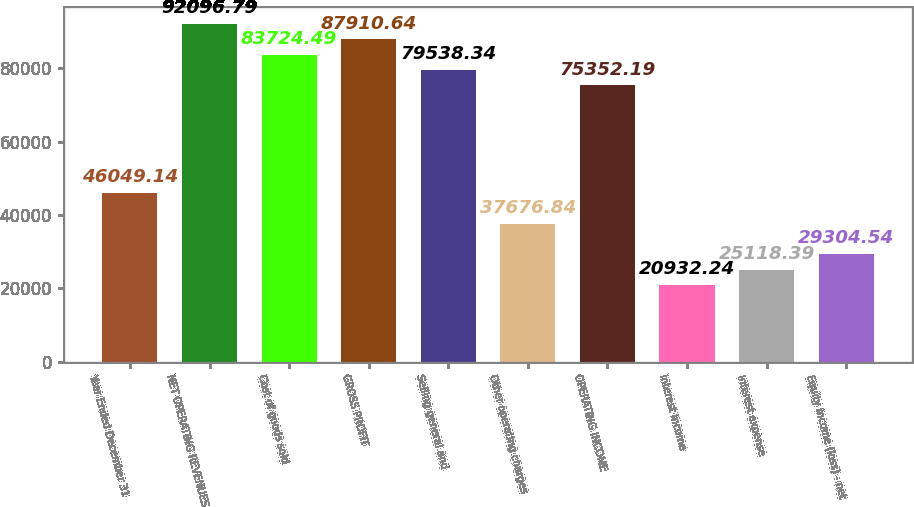<chart> <loc_0><loc_0><loc_500><loc_500><bar_chart><fcel>Year Ended December 31<fcel>NET OPERATING REVENUES<fcel>Cost of goods sold<fcel>GROSS PROFIT<fcel>Selling general and<fcel>Other operating charges<fcel>OPERATING INCOME<fcel>Interest income<fcel>Interest expense<fcel>Equity income (loss) - net<nl><fcel>46049.1<fcel>92096.8<fcel>83724.5<fcel>87910.6<fcel>79538.3<fcel>37676.8<fcel>75352.2<fcel>20932.2<fcel>25118.4<fcel>29304.5<nl></chart> 